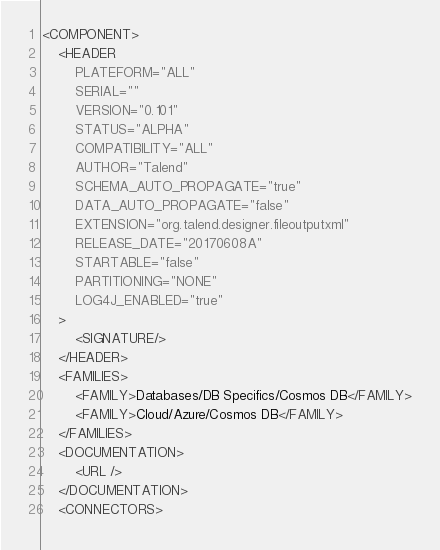<code> <loc_0><loc_0><loc_500><loc_500><_XML_><COMPONENT>
    <HEADER
        PLATEFORM="ALL"
        SERIAL=""
        VERSION="0.101"
        STATUS="ALPHA"
        COMPATIBILITY="ALL"
        AUTHOR="Talend"
        SCHEMA_AUTO_PROPAGATE="true"
        DATA_AUTO_PROPAGATE="false"
        EXTENSION="org.talend.designer.fileoutputxml"
        RELEASE_DATE="20170608A"
        STARTABLE="false"
        PARTITIONING="NONE"
        LOG4J_ENABLED="true"
    >
        <SIGNATURE/>
    </HEADER>
    <FAMILIES>
        <FAMILY>Databases/DB Specifics/Cosmos DB</FAMILY>
        <FAMILY>Cloud/Azure/Cosmos DB</FAMILY>
    </FAMILIES>
    <DOCUMENTATION>
        <URL />
    </DOCUMENTATION>
    <CONNECTORS></code> 